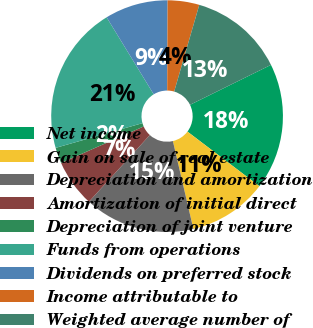<chart> <loc_0><loc_0><loc_500><loc_500><pie_chart><fcel>Net income<fcel>Gain on sale of real estate<fcel>Depreciation and amortization<fcel>Amortization of initial direct<fcel>Depreciation of joint venture<fcel>Funds from operations<fcel>Dividends on preferred stock<fcel>Income attributable to<fcel>Weighted average number of<nl><fcel>17.63%<fcel>11.02%<fcel>15.42%<fcel>6.61%<fcel>2.2%<fcel>20.68%<fcel>8.81%<fcel>4.41%<fcel>13.22%<nl></chart> 